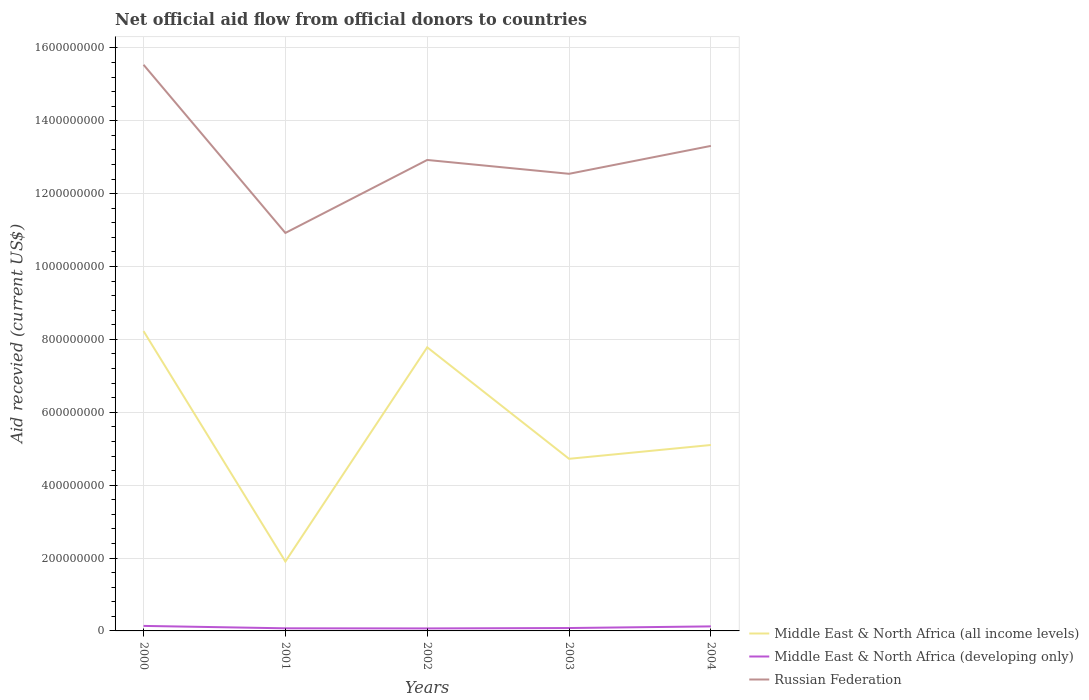How many different coloured lines are there?
Provide a short and direct response. 3. Across all years, what is the maximum total aid received in Russian Federation?
Your answer should be very brief. 1.09e+09. What is the total total aid received in Middle East & North Africa (developing only) in the graph?
Your answer should be very brief. 2.60e+05. What is the difference between the highest and the second highest total aid received in Middle East & North Africa (developing only)?
Give a very brief answer. 6.87e+06. Is the total aid received in Middle East & North Africa (all income levels) strictly greater than the total aid received in Russian Federation over the years?
Provide a succinct answer. Yes. How many years are there in the graph?
Make the answer very short. 5. What is the difference between two consecutive major ticks on the Y-axis?
Provide a succinct answer. 2.00e+08. Where does the legend appear in the graph?
Make the answer very short. Bottom right. What is the title of the graph?
Provide a succinct answer. Net official aid flow from official donors to countries. Does "Gambia, The" appear as one of the legend labels in the graph?
Ensure brevity in your answer.  No. What is the label or title of the X-axis?
Ensure brevity in your answer.  Years. What is the label or title of the Y-axis?
Provide a short and direct response. Aid recevied (current US$). What is the Aid recevied (current US$) in Middle East & North Africa (all income levels) in 2000?
Provide a short and direct response. 8.23e+08. What is the Aid recevied (current US$) of Middle East & North Africa (developing only) in 2000?
Provide a short and direct response. 1.38e+07. What is the Aid recevied (current US$) in Russian Federation in 2000?
Give a very brief answer. 1.55e+09. What is the Aid recevied (current US$) of Middle East & North Africa (all income levels) in 2001?
Ensure brevity in your answer.  1.90e+08. What is the Aid recevied (current US$) in Middle East & North Africa (developing only) in 2001?
Your response must be concise. 7.14e+06. What is the Aid recevied (current US$) in Russian Federation in 2001?
Your response must be concise. 1.09e+09. What is the Aid recevied (current US$) of Middle East & North Africa (all income levels) in 2002?
Provide a succinct answer. 7.78e+08. What is the Aid recevied (current US$) of Middle East & North Africa (developing only) in 2002?
Your answer should be compact. 6.88e+06. What is the Aid recevied (current US$) in Russian Federation in 2002?
Offer a very short reply. 1.29e+09. What is the Aid recevied (current US$) of Middle East & North Africa (all income levels) in 2003?
Give a very brief answer. 4.72e+08. What is the Aid recevied (current US$) in Middle East & North Africa (developing only) in 2003?
Give a very brief answer. 7.95e+06. What is the Aid recevied (current US$) in Russian Federation in 2003?
Make the answer very short. 1.25e+09. What is the Aid recevied (current US$) in Middle East & North Africa (all income levels) in 2004?
Offer a very short reply. 5.10e+08. What is the Aid recevied (current US$) of Middle East & North Africa (developing only) in 2004?
Give a very brief answer. 1.24e+07. What is the Aid recevied (current US$) of Russian Federation in 2004?
Your answer should be very brief. 1.33e+09. Across all years, what is the maximum Aid recevied (current US$) of Middle East & North Africa (all income levels)?
Offer a very short reply. 8.23e+08. Across all years, what is the maximum Aid recevied (current US$) of Middle East & North Africa (developing only)?
Give a very brief answer. 1.38e+07. Across all years, what is the maximum Aid recevied (current US$) of Russian Federation?
Your response must be concise. 1.55e+09. Across all years, what is the minimum Aid recevied (current US$) of Middle East & North Africa (all income levels)?
Provide a succinct answer. 1.90e+08. Across all years, what is the minimum Aid recevied (current US$) of Middle East & North Africa (developing only)?
Provide a short and direct response. 6.88e+06. Across all years, what is the minimum Aid recevied (current US$) of Russian Federation?
Give a very brief answer. 1.09e+09. What is the total Aid recevied (current US$) of Middle East & North Africa (all income levels) in the graph?
Your response must be concise. 2.77e+09. What is the total Aid recevied (current US$) in Middle East & North Africa (developing only) in the graph?
Give a very brief answer. 4.82e+07. What is the total Aid recevied (current US$) in Russian Federation in the graph?
Give a very brief answer. 6.52e+09. What is the difference between the Aid recevied (current US$) of Middle East & North Africa (all income levels) in 2000 and that in 2001?
Ensure brevity in your answer.  6.32e+08. What is the difference between the Aid recevied (current US$) in Middle East & North Africa (developing only) in 2000 and that in 2001?
Keep it short and to the point. 6.61e+06. What is the difference between the Aid recevied (current US$) in Russian Federation in 2000 and that in 2001?
Provide a succinct answer. 4.62e+08. What is the difference between the Aid recevied (current US$) of Middle East & North Africa (all income levels) in 2000 and that in 2002?
Provide a succinct answer. 4.45e+07. What is the difference between the Aid recevied (current US$) in Middle East & North Africa (developing only) in 2000 and that in 2002?
Make the answer very short. 6.87e+06. What is the difference between the Aid recevied (current US$) in Russian Federation in 2000 and that in 2002?
Give a very brief answer. 2.61e+08. What is the difference between the Aid recevied (current US$) in Middle East & North Africa (all income levels) in 2000 and that in 2003?
Provide a succinct answer. 3.50e+08. What is the difference between the Aid recevied (current US$) of Middle East & North Africa (developing only) in 2000 and that in 2003?
Offer a very short reply. 5.80e+06. What is the difference between the Aid recevied (current US$) in Russian Federation in 2000 and that in 2003?
Make the answer very short. 2.99e+08. What is the difference between the Aid recevied (current US$) in Middle East & North Africa (all income levels) in 2000 and that in 2004?
Offer a very short reply. 3.13e+08. What is the difference between the Aid recevied (current US$) in Middle East & North Africa (developing only) in 2000 and that in 2004?
Your answer should be compact. 1.32e+06. What is the difference between the Aid recevied (current US$) in Russian Federation in 2000 and that in 2004?
Make the answer very short. 2.23e+08. What is the difference between the Aid recevied (current US$) in Middle East & North Africa (all income levels) in 2001 and that in 2002?
Your response must be concise. -5.88e+08. What is the difference between the Aid recevied (current US$) of Russian Federation in 2001 and that in 2002?
Offer a very short reply. -2.00e+08. What is the difference between the Aid recevied (current US$) of Middle East & North Africa (all income levels) in 2001 and that in 2003?
Ensure brevity in your answer.  -2.82e+08. What is the difference between the Aid recevied (current US$) of Middle East & North Africa (developing only) in 2001 and that in 2003?
Provide a short and direct response. -8.10e+05. What is the difference between the Aid recevied (current US$) in Russian Federation in 2001 and that in 2003?
Ensure brevity in your answer.  -1.62e+08. What is the difference between the Aid recevied (current US$) of Middle East & North Africa (all income levels) in 2001 and that in 2004?
Give a very brief answer. -3.20e+08. What is the difference between the Aid recevied (current US$) of Middle East & North Africa (developing only) in 2001 and that in 2004?
Provide a succinct answer. -5.29e+06. What is the difference between the Aid recevied (current US$) of Russian Federation in 2001 and that in 2004?
Keep it short and to the point. -2.39e+08. What is the difference between the Aid recevied (current US$) in Middle East & North Africa (all income levels) in 2002 and that in 2003?
Make the answer very short. 3.06e+08. What is the difference between the Aid recevied (current US$) in Middle East & North Africa (developing only) in 2002 and that in 2003?
Offer a very short reply. -1.07e+06. What is the difference between the Aid recevied (current US$) of Russian Federation in 2002 and that in 2003?
Your response must be concise. 3.80e+07. What is the difference between the Aid recevied (current US$) in Middle East & North Africa (all income levels) in 2002 and that in 2004?
Your response must be concise. 2.68e+08. What is the difference between the Aid recevied (current US$) of Middle East & North Africa (developing only) in 2002 and that in 2004?
Make the answer very short. -5.55e+06. What is the difference between the Aid recevied (current US$) in Russian Federation in 2002 and that in 2004?
Ensure brevity in your answer.  -3.86e+07. What is the difference between the Aid recevied (current US$) in Middle East & North Africa (all income levels) in 2003 and that in 2004?
Provide a short and direct response. -3.79e+07. What is the difference between the Aid recevied (current US$) of Middle East & North Africa (developing only) in 2003 and that in 2004?
Provide a succinct answer. -4.48e+06. What is the difference between the Aid recevied (current US$) in Russian Federation in 2003 and that in 2004?
Provide a succinct answer. -7.66e+07. What is the difference between the Aid recevied (current US$) of Middle East & North Africa (all income levels) in 2000 and the Aid recevied (current US$) of Middle East & North Africa (developing only) in 2001?
Offer a very short reply. 8.16e+08. What is the difference between the Aid recevied (current US$) in Middle East & North Africa (all income levels) in 2000 and the Aid recevied (current US$) in Russian Federation in 2001?
Your response must be concise. -2.69e+08. What is the difference between the Aid recevied (current US$) of Middle East & North Africa (developing only) in 2000 and the Aid recevied (current US$) of Russian Federation in 2001?
Give a very brief answer. -1.08e+09. What is the difference between the Aid recevied (current US$) in Middle East & North Africa (all income levels) in 2000 and the Aid recevied (current US$) in Middle East & North Africa (developing only) in 2002?
Offer a very short reply. 8.16e+08. What is the difference between the Aid recevied (current US$) of Middle East & North Africa (all income levels) in 2000 and the Aid recevied (current US$) of Russian Federation in 2002?
Offer a terse response. -4.70e+08. What is the difference between the Aid recevied (current US$) in Middle East & North Africa (developing only) in 2000 and the Aid recevied (current US$) in Russian Federation in 2002?
Ensure brevity in your answer.  -1.28e+09. What is the difference between the Aid recevied (current US$) of Middle East & North Africa (all income levels) in 2000 and the Aid recevied (current US$) of Middle East & North Africa (developing only) in 2003?
Provide a succinct answer. 8.15e+08. What is the difference between the Aid recevied (current US$) in Middle East & North Africa (all income levels) in 2000 and the Aid recevied (current US$) in Russian Federation in 2003?
Your response must be concise. -4.32e+08. What is the difference between the Aid recevied (current US$) in Middle East & North Africa (developing only) in 2000 and the Aid recevied (current US$) in Russian Federation in 2003?
Your response must be concise. -1.24e+09. What is the difference between the Aid recevied (current US$) of Middle East & North Africa (all income levels) in 2000 and the Aid recevied (current US$) of Middle East & North Africa (developing only) in 2004?
Give a very brief answer. 8.10e+08. What is the difference between the Aid recevied (current US$) of Middle East & North Africa (all income levels) in 2000 and the Aid recevied (current US$) of Russian Federation in 2004?
Make the answer very short. -5.08e+08. What is the difference between the Aid recevied (current US$) in Middle East & North Africa (developing only) in 2000 and the Aid recevied (current US$) in Russian Federation in 2004?
Provide a succinct answer. -1.32e+09. What is the difference between the Aid recevied (current US$) in Middle East & North Africa (all income levels) in 2001 and the Aid recevied (current US$) in Middle East & North Africa (developing only) in 2002?
Give a very brief answer. 1.84e+08. What is the difference between the Aid recevied (current US$) in Middle East & North Africa (all income levels) in 2001 and the Aid recevied (current US$) in Russian Federation in 2002?
Offer a very short reply. -1.10e+09. What is the difference between the Aid recevied (current US$) of Middle East & North Africa (developing only) in 2001 and the Aid recevied (current US$) of Russian Federation in 2002?
Offer a very short reply. -1.29e+09. What is the difference between the Aid recevied (current US$) of Middle East & North Africa (all income levels) in 2001 and the Aid recevied (current US$) of Middle East & North Africa (developing only) in 2003?
Provide a succinct answer. 1.83e+08. What is the difference between the Aid recevied (current US$) in Middle East & North Africa (all income levels) in 2001 and the Aid recevied (current US$) in Russian Federation in 2003?
Your answer should be compact. -1.06e+09. What is the difference between the Aid recevied (current US$) in Middle East & North Africa (developing only) in 2001 and the Aid recevied (current US$) in Russian Federation in 2003?
Offer a terse response. -1.25e+09. What is the difference between the Aid recevied (current US$) in Middle East & North Africa (all income levels) in 2001 and the Aid recevied (current US$) in Middle East & North Africa (developing only) in 2004?
Provide a short and direct response. 1.78e+08. What is the difference between the Aid recevied (current US$) of Middle East & North Africa (all income levels) in 2001 and the Aid recevied (current US$) of Russian Federation in 2004?
Give a very brief answer. -1.14e+09. What is the difference between the Aid recevied (current US$) of Middle East & North Africa (developing only) in 2001 and the Aid recevied (current US$) of Russian Federation in 2004?
Your answer should be very brief. -1.32e+09. What is the difference between the Aid recevied (current US$) of Middle East & North Africa (all income levels) in 2002 and the Aid recevied (current US$) of Middle East & North Africa (developing only) in 2003?
Make the answer very short. 7.70e+08. What is the difference between the Aid recevied (current US$) in Middle East & North Africa (all income levels) in 2002 and the Aid recevied (current US$) in Russian Federation in 2003?
Offer a very short reply. -4.76e+08. What is the difference between the Aid recevied (current US$) of Middle East & North Africa (developing only) in 2002 and the Aid recevied (current US$) of Russian Federation in 2003?
Give a very brief answer. -1.25e+09. What is the difference between the Aid recevied (current US$) in Middle East & North Africa (all income levels) in 2002 and the Aid recevied (current US$) in Middle East & North Africa (developing only) in 2004?
Offer a terse response. 7.66e+08. What is the difference between the Aid recevied (current US$) of Middle East & North Africa (all income levels) in 2002 and the Aid recevied (current US$) of Russian Federation in 2004?
Provide a short and direct response. -5.53e+08. What is the difference between the Aid recevied (current US$) in Middle East & North Africa (developing only) in 2002 and the Aid recevied (current US$) in Russian Federation in 2004?
Give a very brief answer. -1.32e+09. What is the difference between the Aid recevied (current US$) of Middle East & North Africa (all income levels) in 2003 and the Aid recevied (current US$) of Middle East & North Africa (developing only) in 2004?
Provide a succinct answer. 4.60e+08. What is the difference between the Aid recevied (current US$) in Middle East & North Africa (all income levels) in 2003 and the Aid recevied (current US$) in Russian Federation in 2004?
Ensure brevity in your answer.  -8.59e+08. What is the difference between the Aid recevied (current US$) in Middle East & North Africa (developing only) in 2003 and the Aid recevied (current US$) in Russian Federation in 2004?
Your answer should be compact. -1.32e+09. What is the average Aid recevied (current US$) in Middle East & North Africa (all income levels) per year?
Your response must be concise. 5.55e+08. What is the average Aid recevied (current US$) of Middle East & North Africa (developing only) per year?
Ensure brevity in your answer.  9.63e+06. What is the average Aid recevied (current US$) in Russian Federation per year?
Give a very brief answer. 1.30e+09. In the year 2000, what is the difference between the Aid recevied (current US$) of Middle East & North Africa (all income levels) and Aid recevied (current US$) of Middle East & North Africa (developing only)?
Your answer should be very brief. 8.09e+08. In the year 2000, what is the difference between the Aid recevied (current US$) of Middle East & North Africa (all income levels) and Aid recevied (current US$) of Russian Federation?
Offer a very short reply. -7.31e+08. In the year 2000, what is the difference between the Aid recevied (current US$) of Middle East & North Africa (developing only) and Aid recevied (current US$) of Russian Federation?
Keep it short and to the point. -1.54e+09. In the year 2001, what is the difference between the Aid recevied (current US$) of Middle East & North Africa (all income levels) and Aid recevied (current US$) of Middle East & North Africa (developing only)?
Provide a succinct answer. 1.83e+08. In the year 2001, what is the difference between the Aid recevied (current US$) in Middle East & North Africa (all income levels) and Aid recevied (current US$) in Russian Federation?
Provide a succinct answer. -9.02e+08. In the year 2001, what is the difference between the Aid recevied (current US$) of Middle East & North Africa (developing only) and Aid recevied (current US$) of Russian Federation?
Your response must be concise. -1.09e+09. In the year 2002, what is the difference between the Aid recevied (current US$) in Middle East & North Africa (all income levels) and Aid recevied (current US$) in Middle East & North Africa (developing only)?
Provide a succinct answer. 7.71e+08. In the year 2002, what is the difference between the Aid recevied (current US$) of Middle East & North Africa (all income levels) and Aid recevied (current US$) of Russian Federation?
Your answer should be very brief. -5.14e+08. In the year 2002, what is the difference between the Aid recevied (current US$) of Middle East & North Africa (developing only) and Aid recevied (current US$) of Russian Federation?
Make the answer very short. -1.29e+09. In the year 2003, what is the difference between the Aid recevied (current US$) in Middle East & North Africa (all income levels) and Aid recevied (current US$) in Middle East & North Africa (developing only)?
Your answer should be compact. 4.64e+08. In the year 2003, what is the difference between the Aid recevied (current US$) in Middle East & North Africa (all income levels) and Aid recevied (current US$) in Russian Federation?
Provide a short and direct response. -7.82e+08. In the year 2003, what is the difference between the Aid recevied (current US$) in Middle East & North Africa (developing only) and Aid recevied (current US$) in Russian Federation?
Keep it short and to the point. -1.25e+09. In the year 2004, what is the difference between the Aid recevied (current US$) of Middle East & North Africa (all income levels) and Aid recevied (current US$) of Middle East & North Africa (developing only)?
Provide a short and direct response. 4.98e+08. In the year 2004, what is the difference between the Aid recevied (current US$) of Middle East & North Africa (all income levels) and Aid recevied (current US$) of Russian Federation?
Give a very brief answer. -8.21e+08. In the year 2004, what is the difference between the Aid recevied (current US$) in Middle East & North Africa (developing only) and Aid recevied (current US$) in Russian Federation?
Provide a short and direct response. -1.32e+09. What is the ratio of the Aid recevied (current US$) of Middle East & North Africa (all income levels) in 2000 to that in 2001?
Your response must be concise. 4.32. What is the ratio of the Aid recevied (current US$) of Middle East & North Africa (developing only) in 2000 to that in 2001?
Keep it short and to the point. 1.93. What is the ratio of the Aid recevied (current US$) in Russian Federation in 2000 to that in 2001?
Your answer should be compact. 1.42. What is the ratio of the Aid recevied (current US$) in Middle East & North Africa (all income levels) in 2000 to that in 2002?
Provide a succinct answer. 1.06. What is the ratio of the Aid recevied (current US$) of Middle East & North Africa (developing only) in 2000 to that in 2002?
Provide a succinct answer. 2. What is the ratio of the Aid recevied (current US$) in Russian Federation in 2000 to that in 2002?
Keep it short and to the point. 1.2. What is the ratio of the Aid recevied (current US$) in Middle East & North Africa (all income levels) in 2000 to that in 2003?
Make the answer very short. 1.74. What is the ratio of the Aid recevied (current US$) of Middle East & North Africa (developing only) in 2000 to that in 2003?
Provide a succinct answer. 1.73. What is the ratio of the Aid recevied (current US$) of Russian Federation in 2000 to that in 2003?
Offer a very short reply. 1.24. What is the ratio of the Aid recevied (current US$) in Middle East & North Africa (all income levels) in 2000 to that in 2004?
Your response must be concise. 1.61. What is the ratio of the Aid recevied (current US$) in Middle East & North Africa (developing only) in 2000 to that in 2004?
Provide a short and direct response. 1.11. What is the ratio of the Aid recevied (current US$) in Russian Federation in 2000 to that in 2004?
Make the answer very short. 1.17. What is the ratio of the Aid recevied (current US$) of Middle East & North Africa (all income levels) in 2001 to that in 2002?
Make the answer very short. 0.24. What is the ratio of the Aid recevied (current US$) in Middle East & North Africa (developing only) in 2001 to that in 2002?
Keep it short and to the point. 1.04. What is the ratio of the Aid recevied (current US$) in Russian Federation in 2001 to that in 2002?
Your answer should be very brief. 0.84. What is the ratio of the Aid recevied (current US$) in Middle East & North Africa (all income levels) in 2001 to that in 2003?
Give a very brief answer. 0.4. What is the ratio of the Aid recevied (current US$) in Middle East & North Africa (developing only) in 2001 to that in 2003?
Your answer should be very brief. 0.9. What is the ratio of the Aid recevied (current US$) in Russian Federation in 2001 to that in 2003?
Your answer should be compact. 0.87. What is the ratio of the Aid recevied (current US$) of Middle East & North Africa (all income levels) in 2001 to that in 2004?
Offer a terse response. 0.37. What is the ratio of the Aid recevied (current US$) of Middle East & North Africa (developing only) in 2001 to that in 2004?
Your answer should be compact. 0.57. What is the ratio of the Aid recevied (current US$) in Russian Federation in 2001 to that in 2004?
Give a very brief answer. 0.82. What is the ratio of the Aid recevied (current US$) in Middle East & North Africa (all income levels) in 2002 to that in 2003?
Provide a short and direct response. 1.65. What is the ratio of the Aid recevied (current US$) in Middle East & North Africa (developing only) in 2002 to that in 2003?
Offer a very short reply. 0.87. What is the ratio of the Aid recevied (current US$) in Russian Federation in 2002 to that in 2003?
Offer a very short reply. 1.03. What is the ratio of the Aid recevied (current US$) of Middle East & North Africa (all income levels) in 2002 to that in 2004?
Keep it short and to the point. 1.53. What is the ratio of the Aid recevied (current US$) of Middle East & North Africa (developing only) in 2002 to that in 2004?
Give a very brief answer. 0.55. What is the ratio of the Aid recevied (current US$) in Middle East & North Africa (all income levels) in 2003 to that in 2004?
Give a very brief answer. 0.93. What is the ratio of the Aid recevied (current US$) of Middle East & North Africa (developing only) in 2003 to that in 2004?
Your answer should be very brief. 0.64. What is the ratio of the Aid recevied (current US$) of Russian Federation in 2003 to that in 2004?
Provide a short and direct response. 0.94. What is the difference between the highest and the second highest Aid recevied (current US$) in Middle East & North Africa (all income levels)?
Make the answer very short. 4.45e+07. What is the difference between the highest and the second highest Aid recevied (current US$) in Middle East & North Africa (developing only)?
Provide a short and direct response. 1.32e+06. What is the difference between the highest and the second highest Aid recevied (current US$) of Russian Federation?
Offer a terse response. 2.23e+08. What is the difference between the highest and the lowest Aid recevied (current US$) of Middle East & North Africa (all income levels)?
Your answer should be compact. 6.32e+08. What is the difference between the highest and the lowest Aid recevied (current US$) in Middle East & North Africa (developing only)?
Offer a terse response. 6.87e+06. What is the difference between the highest and the lowest Aid recevied (current US$) in Russian Federation?
Give a very brief answer. 4.62e+08. 